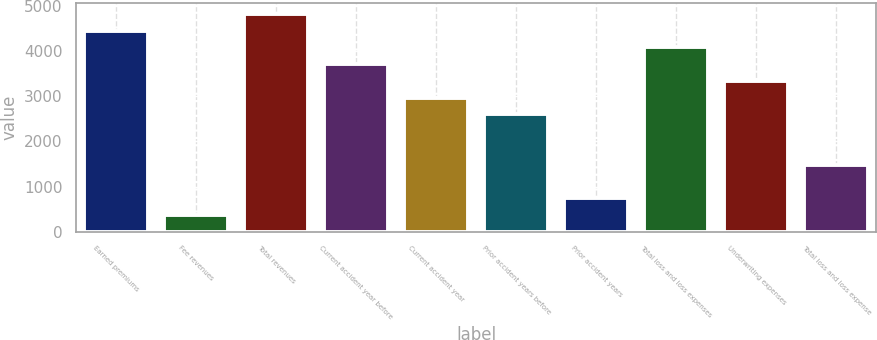Convert chart to OTSL. <chart><loc_0><loc_0><loc_500><loc_500><bar_chart><fcel>Earned premiums<fcel>Fee revenues<fcel>Total revenues<fcel>Current accident year before<fcel>Current accident year<fcel>Prior accident years before<fcel>Prior accident years<fcel>Total loss and loss expenses<fcel>Underwriting expenses<fcel>Total loss and loss expense<nl><fcel>4460.14<fcel>372.87<fcel>4831.71<fcel>3717<fcel>2973.86<fcel>2602.29<fcel>744.44<fcel>4088.57<fcel>3345.43<fcel>1487.58<nl></chart> 